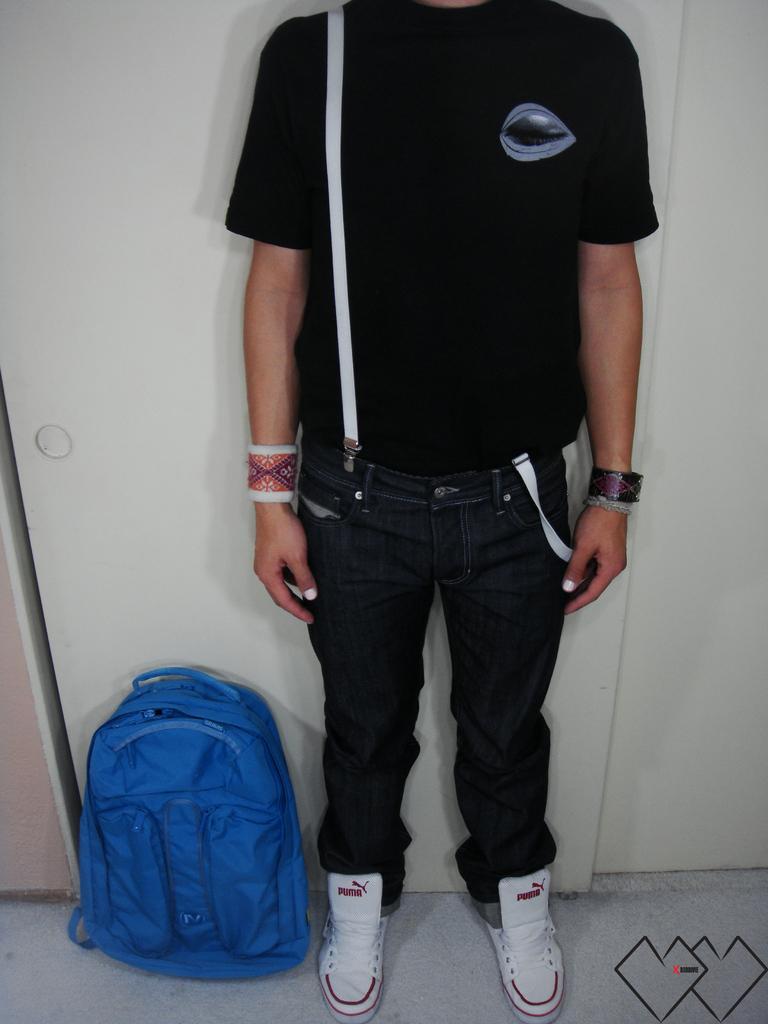How would you summarize this image in a sentence or two? In this picture we can see a man whose head is covered and he is in black shirt, black jeans and white shoes and beside him there is a blue backpack. 